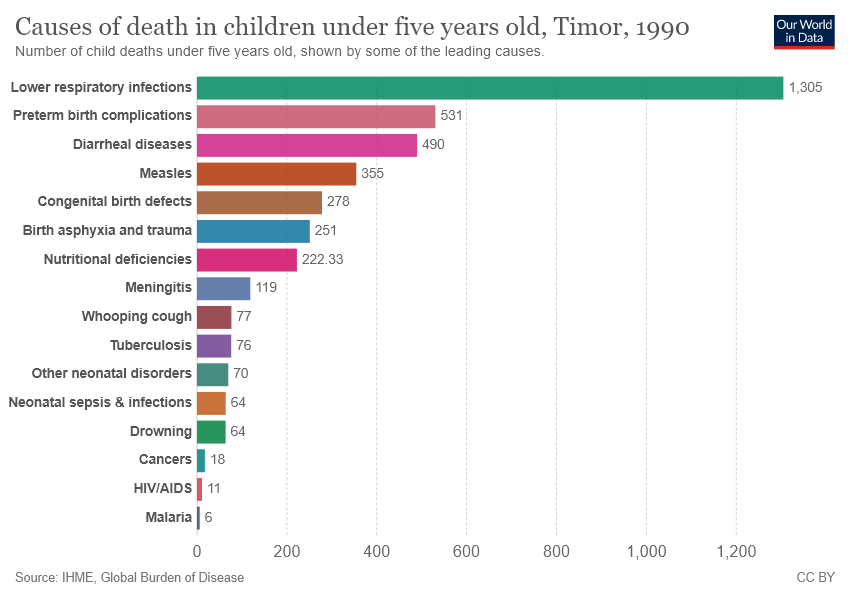Point out several critical features in this image. The median value is smaller than the average value. What is the value of Cancers, 18... 